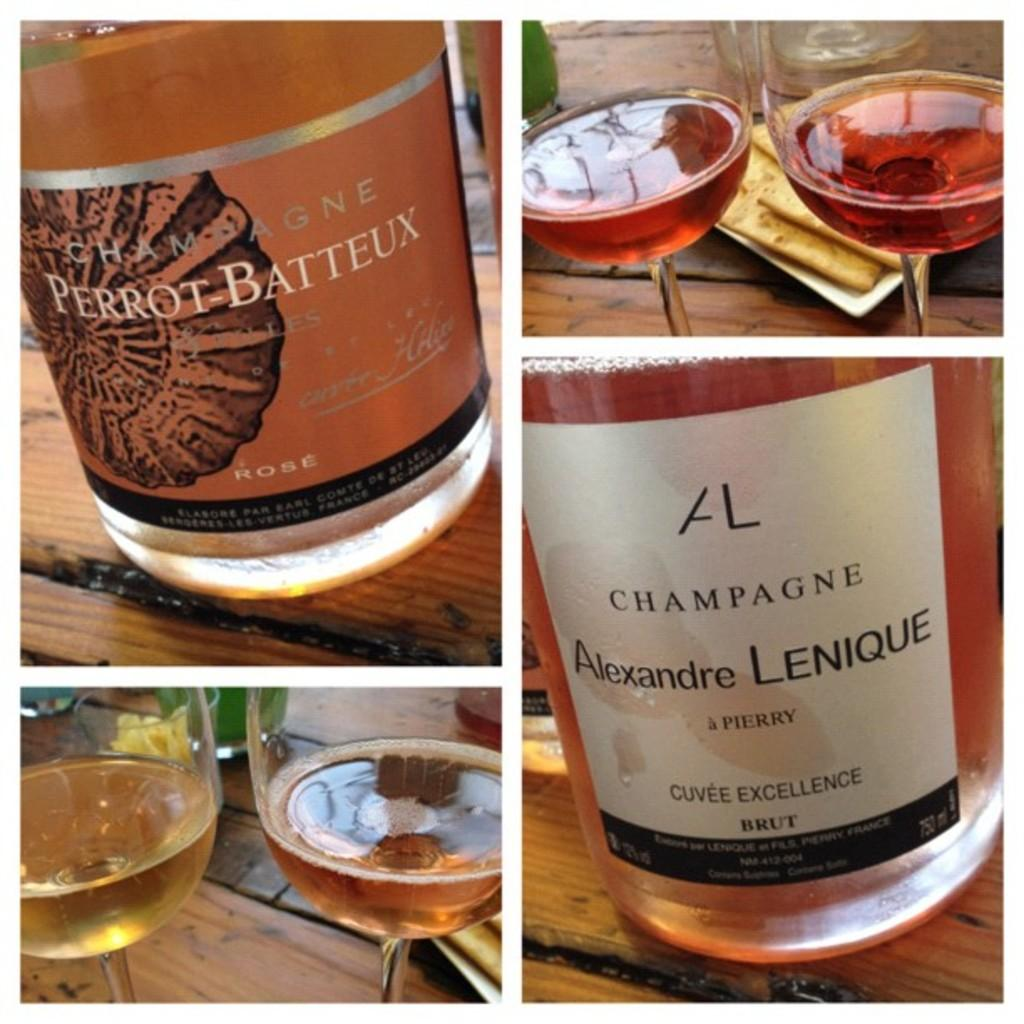Provide a one-sentence caption for the provided image. Two bottles of champagne are called "PERROT BATTEUX" and "Alexandre LENIQUE". 